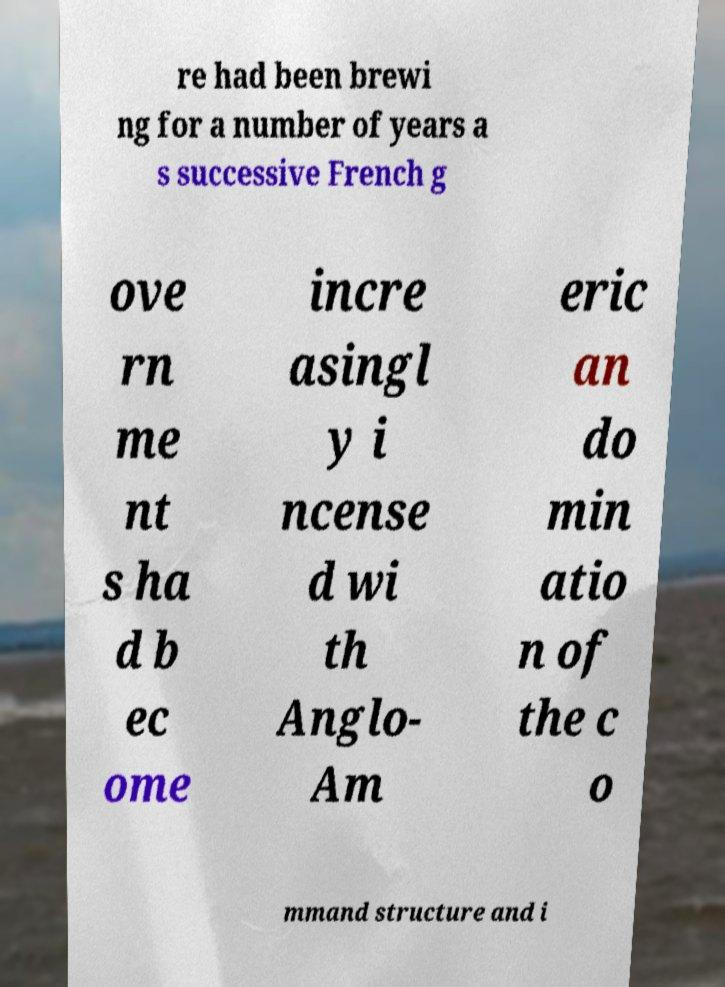Could you assist in decoding the text presented in this image and type it out clearly? re had been brewi ng for a number of years a s successive French g ove rn me nt s ha d b ec ome incre asingl y i ncense d wi th Anglo- Am eric an do min atio n of the c o mmand structure and i 